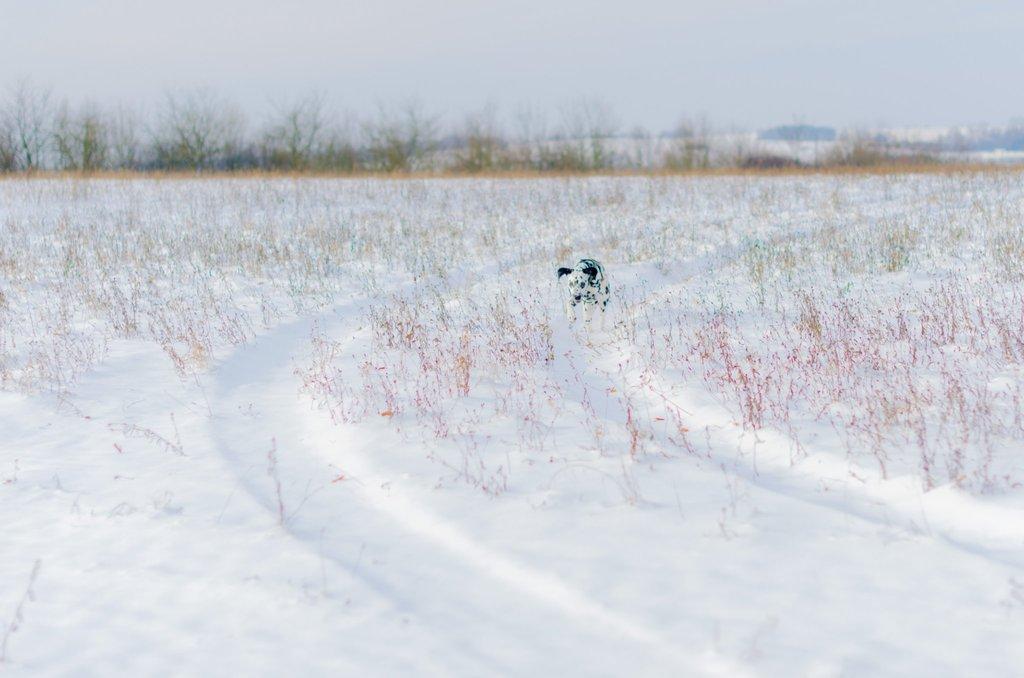Please provide a concise description of this image. In this image there is the sky towards the top of the image, there are trees towards the left of the image, there is ice towards the bottom of the image, there are plants, there is an animal. 